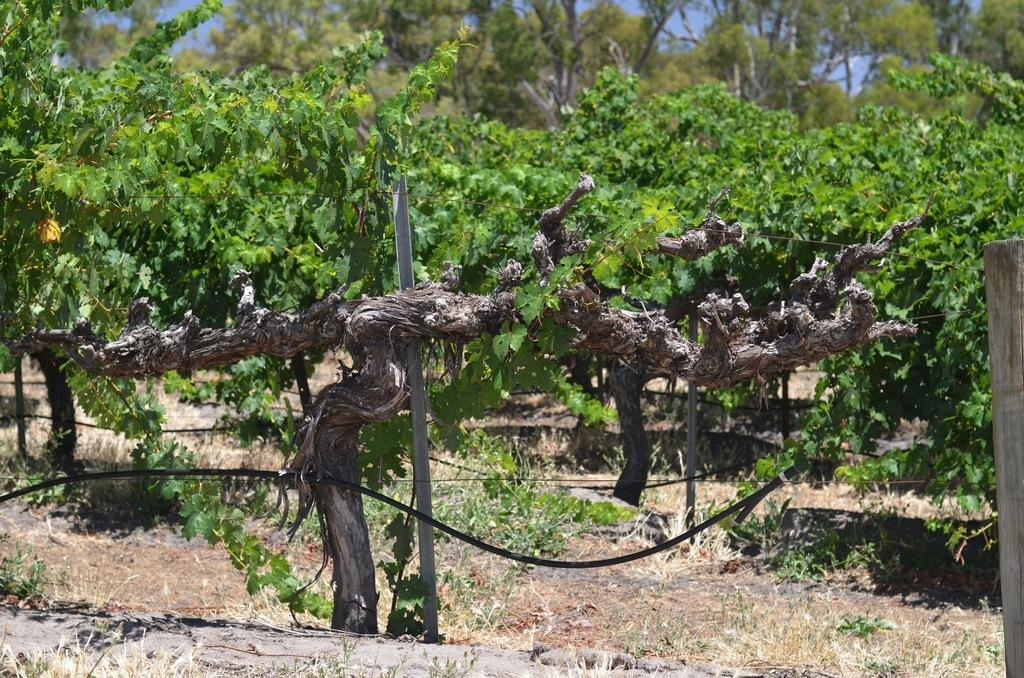What type of vegetation can be seen in the image? There are trees and plants in the image. What is located in the middle of the image? There is a pole and a pipe in the middle of the image. What type of caption is written on the root of the tree in the image? There is no caption written on the root of the tree in the image, as there are no roots or captions mentioned in the facts. 